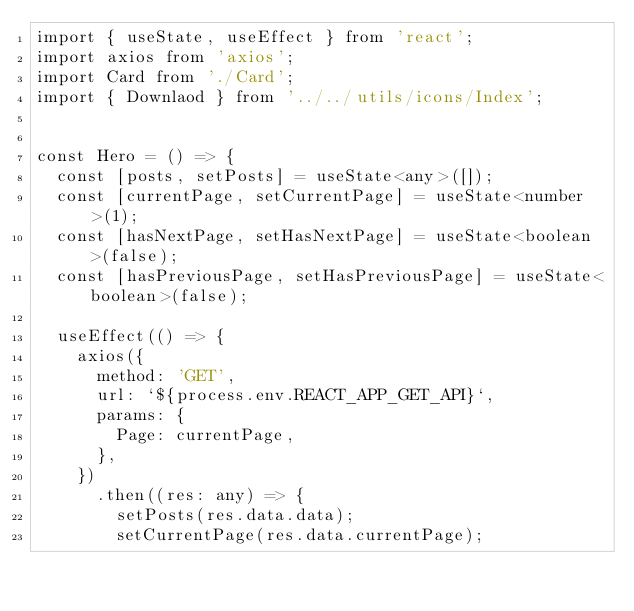Convert code to text. <code><loc_0><loc_0><loc_500><loc_500><_TypeScript_>import { useState, useEffect } from 'react';
import axios from 'axios';
import Card from './Card';
import { Downlaod } from '../../utils/icons/Index';


const Hero = () => {
  const [posts, setPosts] = useState<any>([]);
  const [currentPage, setCurrentPage] = useState<number>(1);
  const [hasNextPage, setHasNextPage] = useState<boolean>(false);
  const [hasPreviousPage, setHasPreviousPage] = useState<boolean>(false);

  useEffect(() => {
    axios({
      method: 'GET',
      url: `${process.env.REACT_APP_GET_API}`,
      params: {
        Page: currentPage,
      },
    })
      .then((res: any) => {
        setPosts(res.data.data);
        setCurrentPage(res.data.currentPage);</code> 